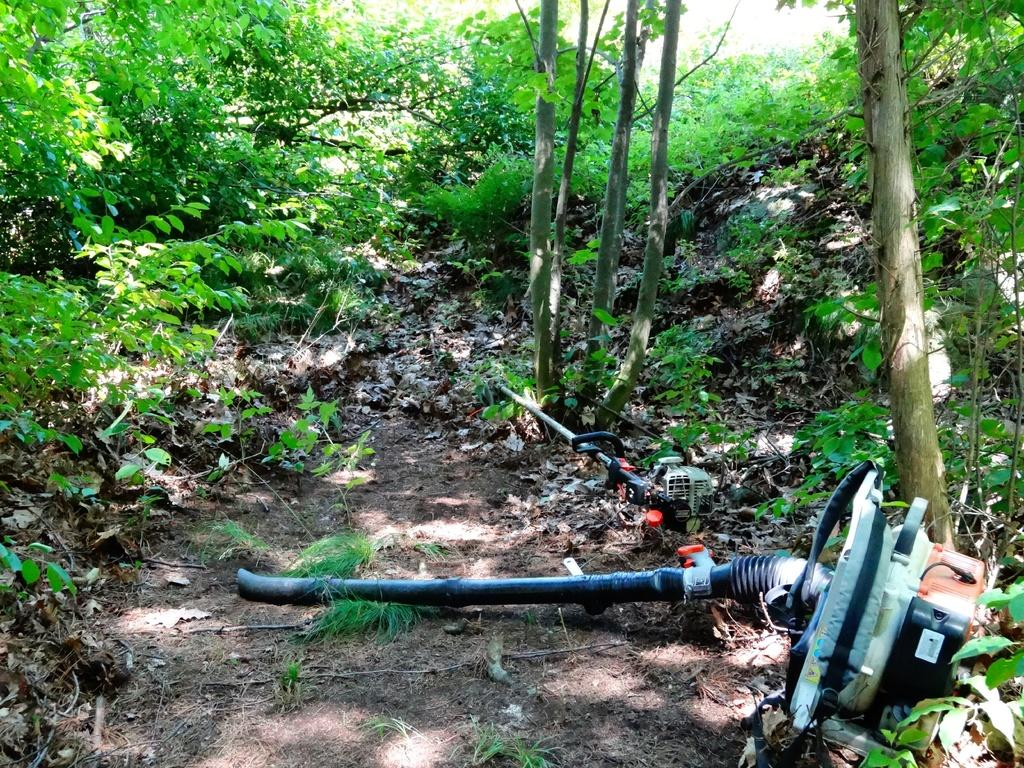What are the two objects on the ground in the image? There are two objects that look like motors on the ground. What type of natural elements can be seen in the image? There are trees and plants in the image. What type of caption is written on the motors in the image? There is no caption written on the motors in the image; they are simply objects on the ground. 